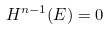<formula> <loc_0><loc_0><loc_500><loc_500>H ^ { n - 1 } ( E ) = 0</formula> 